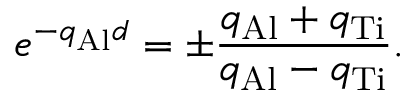Convert formula to latex. <formula><loc_0><loc_0><loc_500><loc_500>e ^ { - q _ { A l } d } = \pm \frac { q _ { A l } + q _ { T i } } { q _ { A l } - q _ { T i } } .</formula> 